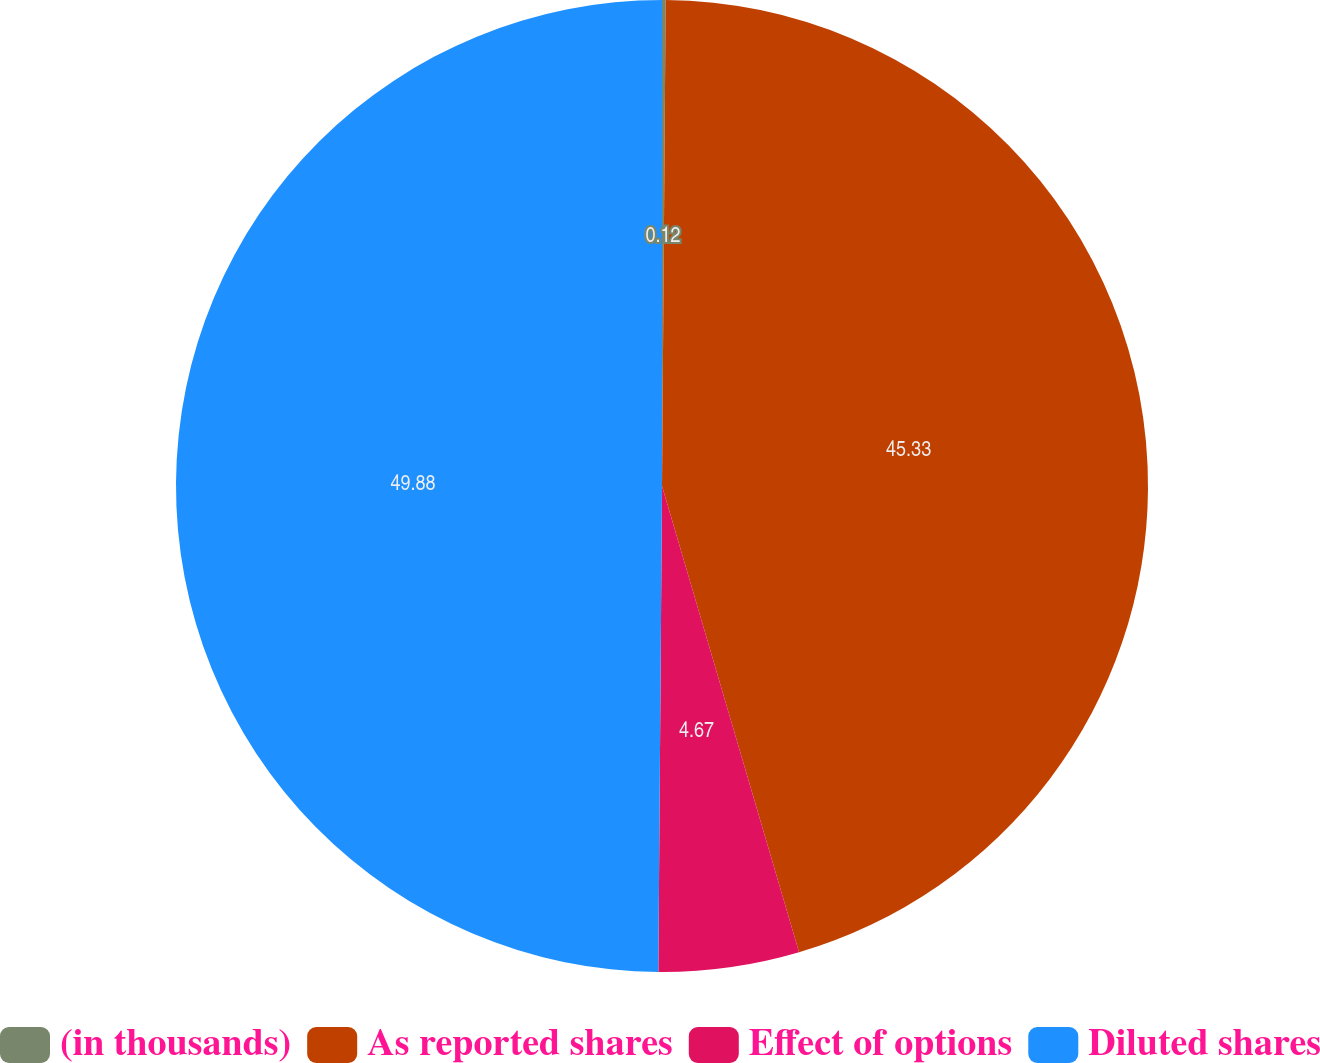Convert chart. <chart><loc_0><loc_0><loc_500><loc_500><pie_chart><fcel>(in thousands)<fcel>As reported shares<fcel>Effect of options<fcel>Diluted shares<nl><fcel>0.12%<fcel>45.33%<fcel>4.67%<fcel>49.88%<nl></chart> 